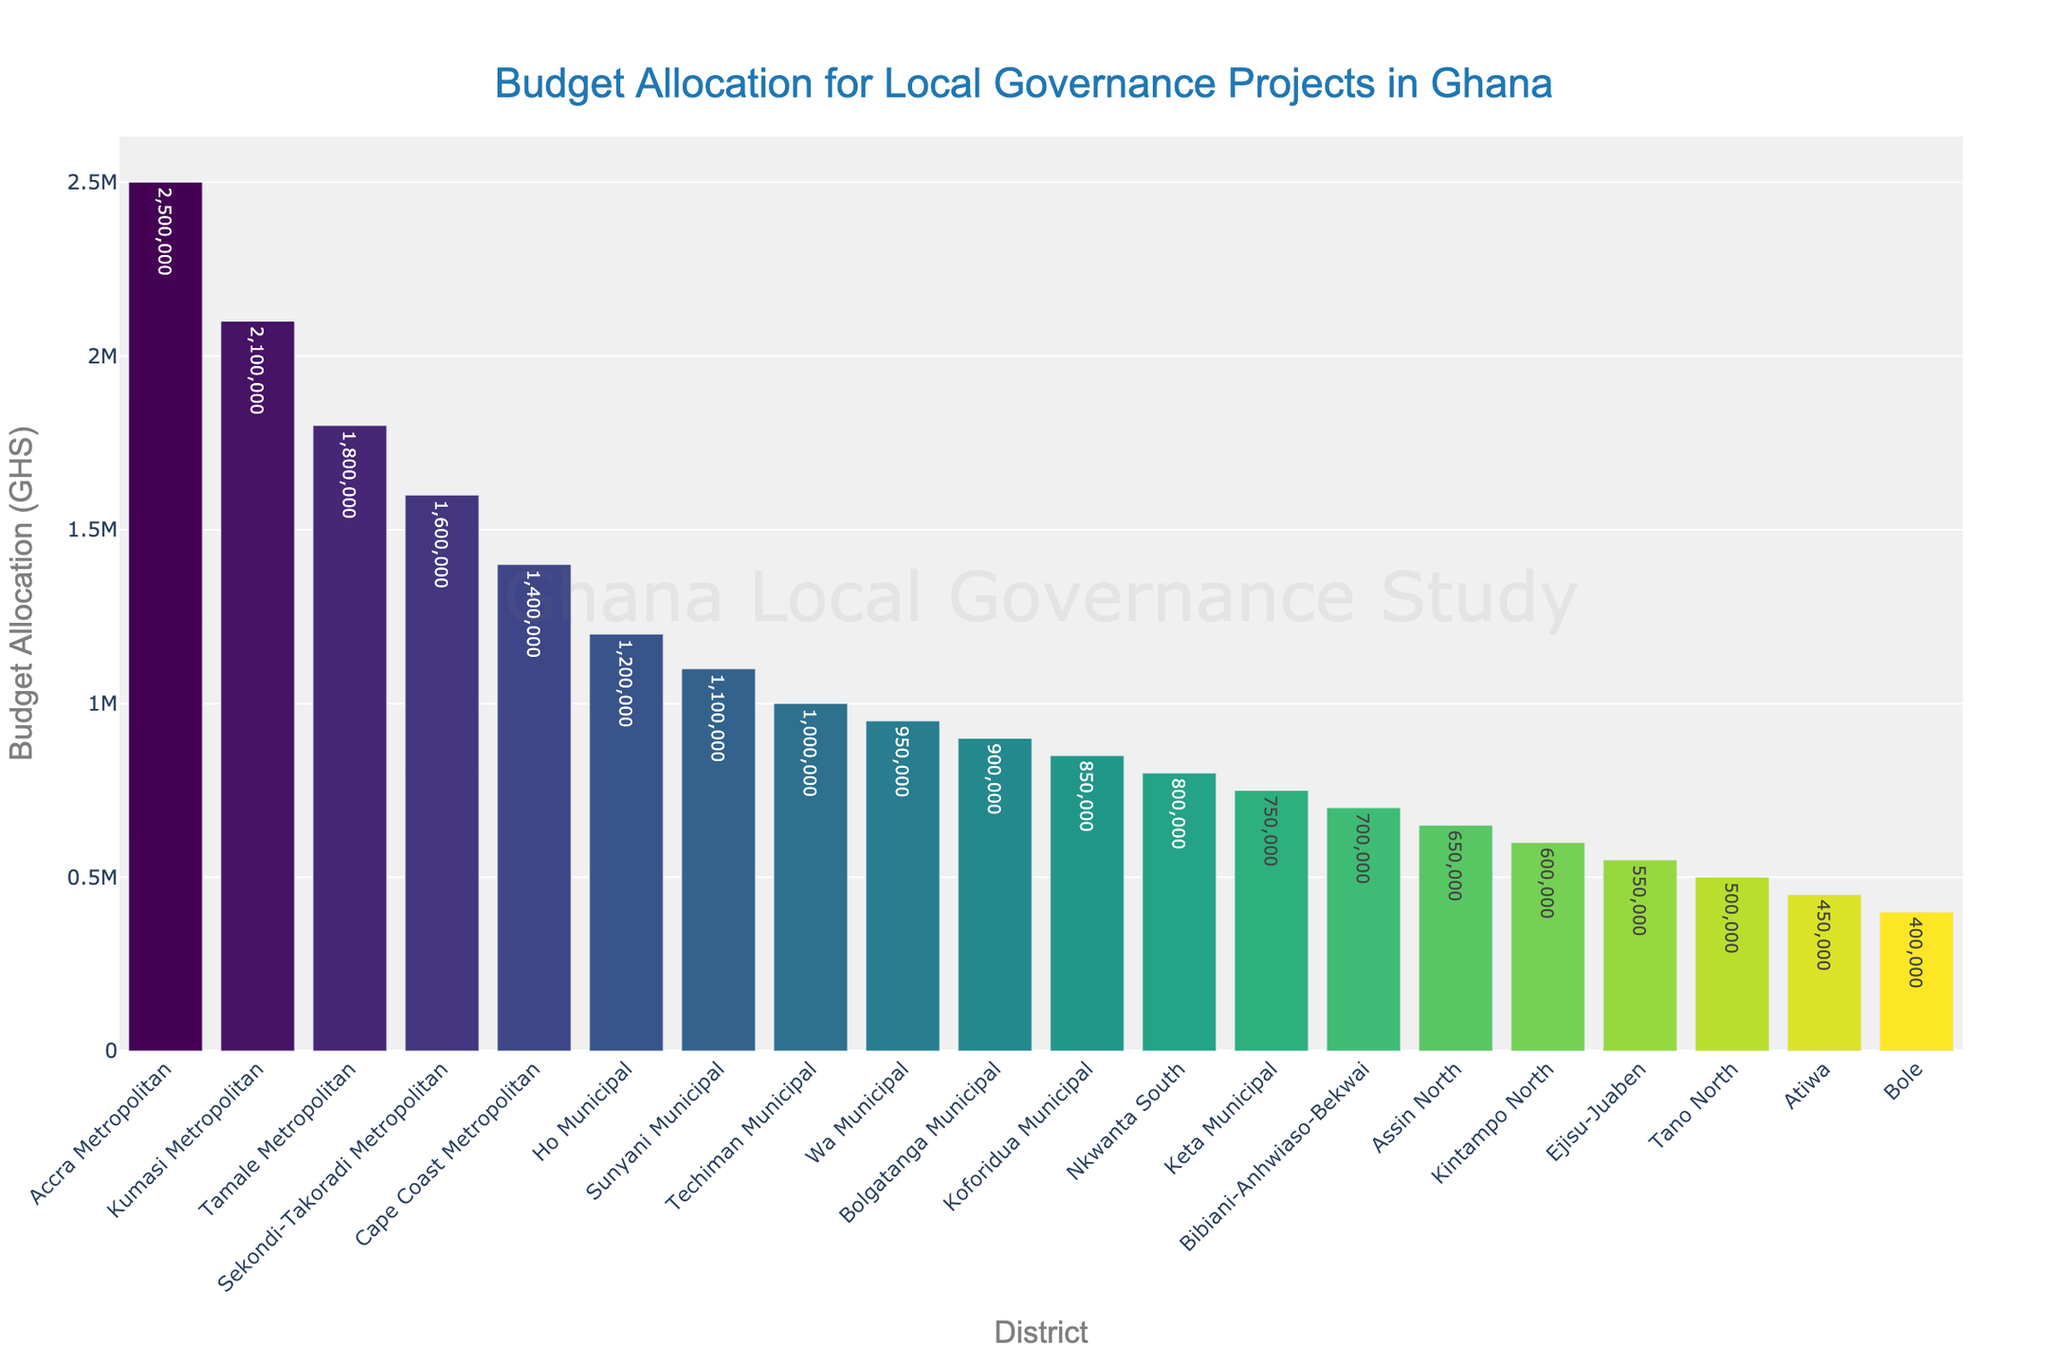Which district has the highest budget allocation? The highest bar on the chart corresponds to Accra Metropolitan, indicating it has the highest budget allocation.
Answer: Accra Metropolitan Which two districts have the lowest budget allocations? The two shortest bars represent Bole and Atiwa, indicating these districts have the lowest budget allocations.
Answer: Bole and Atiwa What is the difference in budget allocation between Accra Metropolitan and Kumasi Metropolitan? Accra Metropolitan has a budget of 2,500,000 GHS, and Kumasi Metropolitan has 2,100,000 GHS. The difference is 2,500,000 - 2,100,000 = 400,000 GHS.
Answer: 400,000 GHS How many districts have a budget allocation of over 1,000,000 GHS? Count the bars that have heights corresponding to values over 1,000,000 GHS. These districts are Accra Metropolitan, Kumasi Metropolitan, Tamale Metropolitan, Sekondi-Takoradi Metropolitan, Cape Coast Metropolitan, and Ho Municipal. This totals six districts.
Answer: 6 Compare the budget allocation of Tamale Metropolitan and Sunyani Municipal. Which one has more, and by how much? Tamale Metropolitan has 1,800,000 GHS, and Sunyani Municipal has 1,100,000 GHS. Tamale Metropolitan has more by 1,800,000 - 1,100,000 = 700,000 GHS.
Answer: Tamale Metropolitan by 700,000 GHS What is the total budget allocation for the top three districts? The top three districts are Accra Metropolitan (2,500,000 GHS), Kumasi Metropolitan (2,100,000 GHS), and Tamale Metropolitan (1,800,000 GHS). The total is 2,500,000 + 2,100,000 + 1,800,000 = 6,400,000 GHS.
Answer: 6,400,000 GHS Is the budget allocation for Ho Municipal more than the combined allocation for Keta Municipal and Bibiani-Anhwiaso-Bekwai? Ho Municipal has 1,200,000 GHS. Keta Municipal has 750,000 GHS, and Bibiani-Anhwiaso-Bekwai has 700,000 GHS. Combined, Keta Municipal and Bibiani-Anhwiaso-Bekwai have 750,000 + 700,000 = 1,450,000 GHS. Since 1,200,000 is less than 1,450,000, the answer is no.
Answer: No What is the average budget allocation of the districts with less than 1,000,000 GHS? The districts with less than 1,000,000 GHS are Wa Municipal (950,000 GHS), Bolgatanga Municipal (900,000 GHS), Koforidua Municipal (850,000 GHS), Nkwanta South (800,000 GHS), Keta Municipal (750,000 GHS), Bibiani-Anhwiaso-Bekwai (700,000 GHS), Assin North (650,000 GHS), Kintampo North (600,000 GHS), Ejisu-Juaben (550,000 GHS), Tano North (500,000 GHS), Atiwa (450,000 GHS), and Bole (400,000 GHS). Total is (950,000 + 900,000 + 850,000 + 800,000 + 750,000 + 700,000 + 650,000 + 600,000 + 550,000 + 500,000 + 450,000 + 400,000) = 8,100,000 GHS. There are 12 districts, so the average is 8,100,000 / 12 = 675,000 GHS.
Answer: 675,000 GHS What is the median budget allocation value? To find the median, sort the budget allocations in ascending order and find the middle value. Sorted values: 400,000, 450,000, 500,000, 550,000, 600,000, 650,000, 700,000, 750,000, 800,000, 850,000, 900,000, 950,000, 1,000,000, 1,100,000, 1,200,000, 1,400,000, 1,600,000, 1,800,000, 2,100,000, 2,500,000. The median of 20 numbers is average of 10th and 11th values: (850,000 + 900,000) / 2 = 875,000 GHS.
Answer: 875,000 GHS Which district stands out visually in terms of its budget allocation, and why? Accra Metropolitan stands out visually because its bar is the tallest, representing the highest budget allocation among all districts.
Answer: Accra Metropolitan 